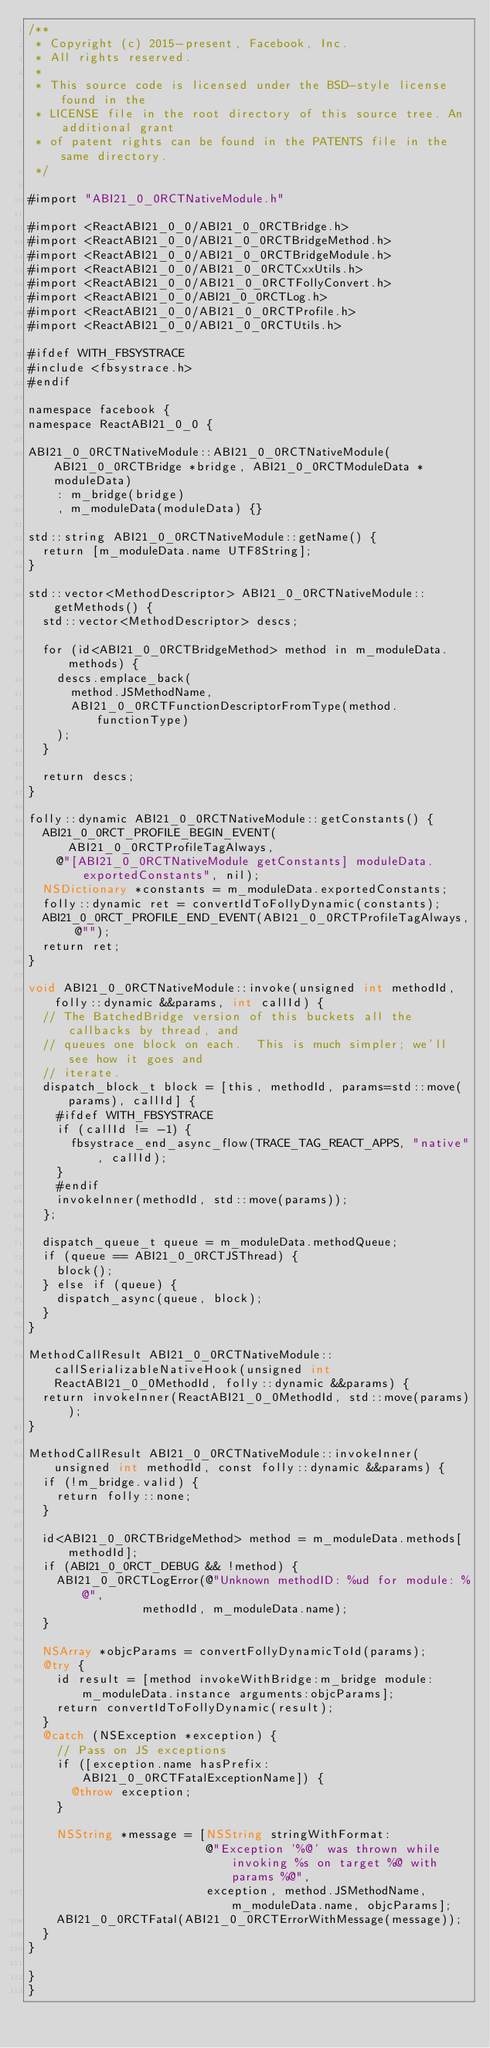<code> <loc_0><loc_0><loc_500><loc_500><_ObjectiveC_>/**
 * Copyright (c) 2015-present, Facebook, Inc.
 * All rights reserved.
 *
 * This source code is licensed under the BSD-style license found in the
 * LICENSE file in the root directory of this source tree. An additional grant
 * of patent rights can be found in the PATENTS file in the same directory.
 */

#import "ABI21_0_0RCTNativeModule.h"

#import <ReactABI21_0_0/ABI21_0_0RCTBridge.h>
#import <ReactABI21_0_0/ABI21_0_0RCTBridgeMethod.h>
#import <ReactABI21_0_0/ABI21_0_0RCTBridgeModule.h>
#import <ReactABI21_0_0/ABI21_0_0RCTCxxUtils.h>
#import <ReactABI21_0_0/ABI21_0_0RCTFollyConvert.h>
#import <ReactABI21_0_0/ABI21_0_0RCTLog.h>
#import <ReactABI21_0_0/ABI21_0_0RCTProfile.h>
#import <ReactABI21_0_0/ABI21_0_0RCTUtils.h>

#ifdef WITH_FBSYSTRACE
#include <fbsystrace.h>
#endif

namespace facebook {
namespace ReactABI21_0_0 {

ABI21_0_0RCTNativeModule::ABI21_0_0RCTNativeModule(ABI21_0_0RCTBridge *bridge, ABI21_0_0RCTModuleData *moduleData)
    : m_bridge(bridge)
    , m_moduleData(moduleData) {}

std::string ABI21_0_0RCTNativeModule::getName() {
  return [m_moduleData.name UTF8String];
}

std::vector<MethodDescriptor> ABI21_0_0RCTNativeModule::getMethods() {
  std::vector<MethodDescriptor> descs;

  for (id<ABI21_0_0RCTBridgeMethod> method in m_moduleData.methods) {
    descs.emplace_back(
      method.JSMethodName,
      ABI21_0_0RCTFunctionDescriptorFromType(method.functionType)
    );
  }

  return descs;
}

folly::dynamic ABI21_0_0RCTNativeModule::getConstants() {
  ABI21_0_0RCT_PROFILE_BEGIN_EVENT(ABI21_0_0RCTProfileTagAlways,
    @"[ABI21_0_0RCTNativeModule getConstants] moduleData.exportedConstants", nil);
  NSDictionary *constants = m_moduleData.exportedConstants;
  folly::dynamic ret = convertIdToFollyDynamic(constants);
  ABI21_0_0RCT_PROFILE_END_EVENT(ABI21_0_0RCTProfileTagAlways, @"");
  return ret;
}

void ABI21_0_0RCTNativeModule::invoke(unsigned int methodId, folly::dynamic &&params, int callId) {
  // The BatchedBridge version of this buckets all the callbacks by thread, and
  // queues one block on each.  This is much simpler; we'll see how it goes and
  // iterate.
  dispatch_block_t block = [this, methodId, params=std::move(params), callId] {
    #ifdef WITH_FBSYSTRACE
    if (callId != -1) {
      fbsystrace_end_async_flow(TRACE_TAG_REACT_APPS, "native", callId);
    }
    #endif
    invokeInner(methodId, std::move(params));
  };

  dispatch_queue_t queue = m_moduleData.methodQueue;
  if (queue == ABI21_0_0RCTJSThread) {
    block();
  } else if (queue) {
    dispatch_async(queue, block);
  }
}

MethodCallResult ABI21_0_0RCTNativeModule::callSerializableNativeHook(unsigned int ReactABI21_0_0MethodId, folly::dynamic &&params) {
  return invokeInner(ReactABI21_0_0MethodId, std::move(params));
}

MethodCallResult ABI21_0_0RCTNativeModule::invokeInner(unsigned int methodId, const folly::dynamic &&params) {
  if (!m_bridge.valid) {
    return folly::none;
  }

  id<ABI21_0_0RCTBridgeMethod> method = m_moduleData.methods[methodId];
  if (ABI21_0_0RCT_DEBUG && !method) {
    ABI21_0_0RCTLogError(@"Unknown methodID: %ud for module: %@",
                methodId, m_moduleData.name);
  }

  NSArray *objcParams = convertFollyDynamicToId(params);
  @try {
    id result = [method invokeWithBridge:m_bridge module:m_moduleData.instance arguments:objcParams];
    return convertIdToFollyDynamic(result);
  }
  @catch (NSException *exception) {
    // Pass on JS exceptions
    if ([exception.name hasPrefix:ABI21_0_0RCTFatalExceptionName]) {
      @throw exception;
    }

    NSString *message = [NSString stringWithFormat:
                         @"Exception '%@' was thrown while invoking %s on target %@ with params %@",
                         exception, method.JSMethodName, m_moduleData.name, objcParams];
    ABI21_0_0RCTFatal(ABI21_0_0RCTErrorWithMessage(message));
  }
}

}
}
</code> 